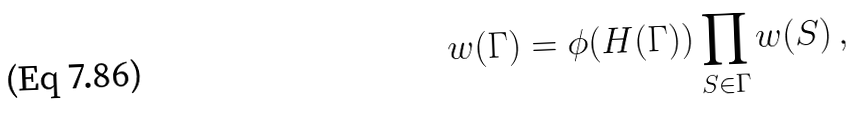Convert formula to latex. <formula><loc_0><loc_0><loc_500><loc_500>w ( \Gamma ) & = \phi ( H ( \Gamma ) ) \prod _ { S \in \Gamma } w ( S ) \, ,</formula> 